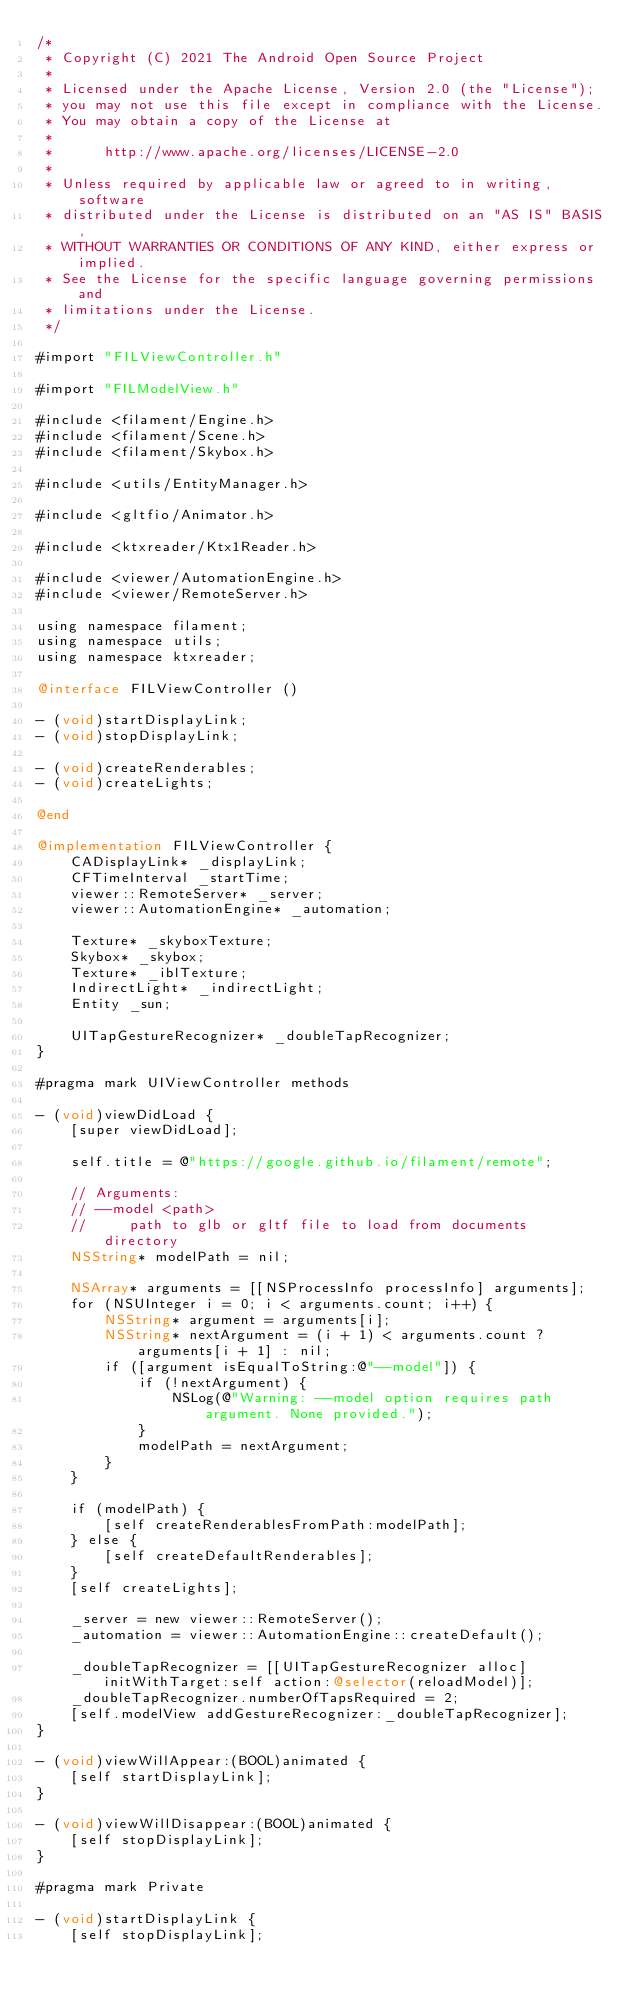<code> <loc_0><loc_0><loc_500><loc_500><_ObjectiveC_>/*
 * Copyright (C) 2021 The Android Open Source Project
 *
 * Licensed under the Apache License, Version 2.0 (the "License");
 * you may not use this file except in compliance with the License.
 * You may obtain a copy of the License at
 *
 *      http://www.apache.org/licenses/LICENSE-2.0
 *
 * Unless required by applicable law or agreed to in writing, software
 * distributed under the License is distributed on an "AS IS" BASIS,
 * WITHOUT WARRANTIES OR CONDITIONS OF ANY KIND, either express or implied.
 * See the License for the specific language governing permissions and
 * limitations under the License.
 */

#import "FILViewController.h"

#import "FILModelView.h"

#include <filament/Engine.h>
#include <filament/Scene.h>
#include <filament/Skybox.h>

#include <utils/EntityManager.h>

#include <gltfio/Animator.h>

#include <ktxreader/Ktx1Reader.h>

#include <viewer/AutomationEngine.h>
#include <viewer/RemoteServer.h>

using namespace filament;
using namespace utils;
using namespace ktxreader;

@interface FILViewController ()

- (void)startDisplayLink;
- (void)stopDisplayLink;

- (void)createRenderables;
- (void)createLights;

@end

@implementation FILViewController {
    CADisplayLink* _displayLink;
    CFTimeInterval _startTime;
    viewer::RemoteServer* _server;
    viewer::AutomationEngine* _automation;

    Texture* _skyboxTexture;
    Skybox* _skybox;
    Texture* _iblTexture;
    IndirectLight* _indirectLight;
    Entity _sun;

    UITapGestureRecognizer* _doubleTapRecognizer;
}

#pragma mark UIViewController methods

- (void)viewDidLoad {
    [super viewDidLoad];

    self.title = @"https://google.github.io/filament/remote";

    // Arguments:
    // --model <path>
    //     path to glb or gltf file to load from documents directory
    NSString* modelPath = nil;

    NSArray* arguments = [[NSProcessInfo processInfo] arguments];
    for (NSUInteger i = 0; i < arguments.count; i++) {
        NSString* argument = arguments[i];
        NSString* nextArgument = (i + 1) < arguments.count ? arguments[i + 1] : nil;
        if ([argument isEqualToString:@"--model"]) {
            if (!nextArgument) {
                NSLog(@"Warning: --model option requires path argument. None provided.");
            }
            modelPath = nextArgument;
        }
    }

    if (modelPath) {
        [self createRenderablesFromPath:modelPath];
    } else {
        [self createDefaultRenderables];
    }
    [self createLights];

    _server = new viewer::RemoteServer();
    _automation = viewer::AutomationEngine::createDefault();

    _doubleTapRecognizer = [[UITapGestureRecognizer alloc] initWithTarget:self action:@selector(reloadModel)];
    _doubleTapRecognizer.numberOfTapsRequired = 2;
    [self.modelView addGestureRecognizer:_doubleTapRecognizer];
}

- (void)viewWillAppear:(BOOL)animated {
    [self startDisplayLink];
}

- (void)viewWillDisappear:(BOOL)animated {
    [self stopDisplayLink];
}

#pragma mark Private

- (void)startDisplayLink {
    [self stopDisplayLink];
</code> 